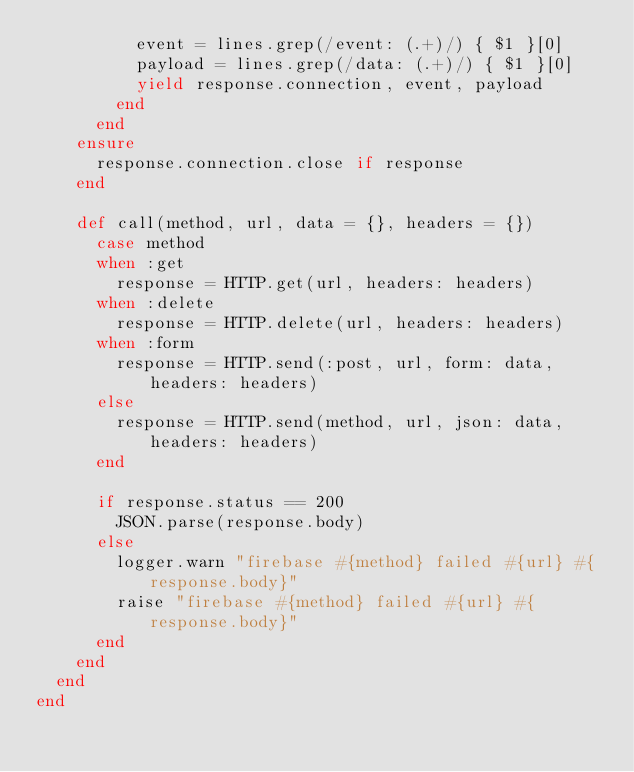<code> <loc_0><loc_0><loc_500><loc_500><_Ruby_>          event = lines.grep(/event: (.+)/) { $1 }[0]
          payload = lines.grep(/data: (.+)/) { $1 }[0]
          yield response.connection, event, payload
        end
      end
    ensure
      response.connection.close if response
    end

    def call(method, url, data = {}, headers = {})
      case method
      when :get
        response = HTTP.get(url, headers: headers)
      when :delete
        response = HTTP.delete(url, headers: headers)
      when :form
        response = HTTP.send(:post, url, form: data, headers: headers)
      else
        response = HTTP.send(method, url, json: data, headers: headers)
      end

      if response.status == 200
        JSON.parse(response.body)
      else
        logger.warn "firebase #{method} failed #{url} #{response.body}"
        raise "firebase #{method} failed #{url} #{response.body}"
      end
    end
  end
end
</code> 